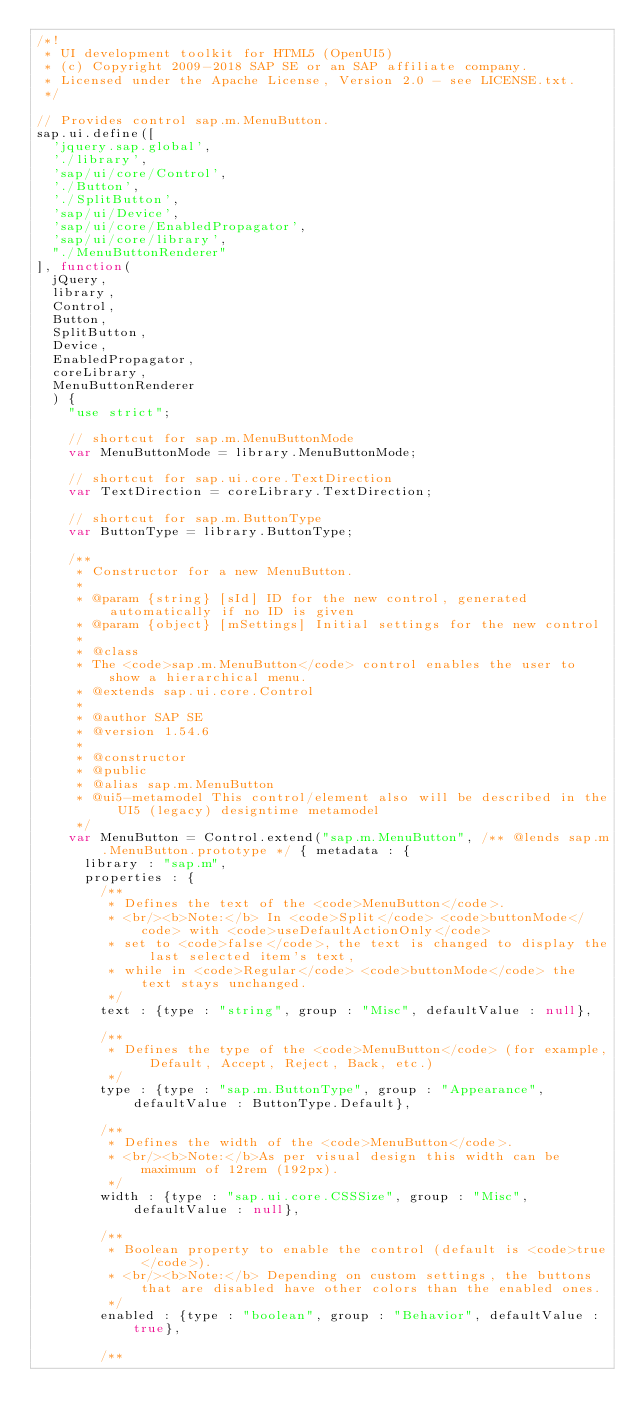<code> <loc_0><loc_0><loc_500><loc_500><_JavaScript_>/*!
 * UI development toolkit for HTML5 (OpenUI5)
 * (c) Copyright 2009-2018 SAP SE or an SAP affiliate company.
 * Licensed under the Apache License, Version 2.0 - see LICENSE.txt.
 */

// Provides control sap.m.MenuButton.
sap.ui.define([
	'jquery.sap.global',
	'./library',
	'sap/ui/core/Control',
	'./Button',
	'./SplitButton',
	'sap/ui/Device',
	'sap/ui/core/EnabledPropagator',
	'sap/ui/core/library',
	"./MenuButtonRenderer"
], function(
	jQuery,
	library,
	Control,
	Button,
	SplitButton,
	Device,
	EnabledPropagator,
	coreLibrary,
	MenuButtonRenderer
	) {
		"use strict";

		// shortcut for sap.m.MenuButtonMode
		var MenuButtonMode = library.MenuButtonMode;

		// shortcut for sap.ui.core.TextDirection
		var TextDirection = coreLibrary.TextDirection;

		// shortcut for sap.m.ButtonType
		var ButtonType = library.ButtonType;

		/**
		 * Constructor for a new MenuButton.
		 *
		 * @param {string} [sId] ID for the new control, generated automatically if no ID is given
		 * @param {object} [mSettings] Initial settings for the new control
		 *
		 * @class
		 * The <code>sap.m.MenuButton</code> control enables the user to show a hierarchical menu.
		 * @extends sap.ui.core.Control
		 *
		 * @author SAP SE
		 * @version 1.54.6
		 *
		 * @constructor
		 * @public
		 * @alias sap.m.MenuButton
		 * @ui5-metamodel This control/element also will be described in the UI5 (legacy) designtime metamodel
		 */
		var MenuButton = Control.extend("sap.m.MenuButton", /** @lends sap.m.MenuButton.prototype */ { metadata : {
			library : "sap.m",
			properties : {
				/**
				 * Defines the text of the <code>MenuButton</code>.
				 * <br/><b>Note:</b> In <code>Split</code> <code>buttonMode</code> with <code>useDefaultActionOnly</code>
				 * set to <code>false</code>, the text is changed to display the last selected item's text,
				 * while in <code>Regular</code> <code>buttonMode</code> the text stays unchanged.
				 */
				text : {type : "string", group : "Misc", defaultValue : null},

				/**
				 * Defines the type of the <code>MenuButton</code> (for example, Default, Accept, Reject, Back, etc.)
				 */
				type : {type : "sap.m.ButtonType", group : "Appearance", defaultValue : ButtonType.Default},

				/**
				 * Defines the width of the <code>MenuButton</code>.
				 * <br/><b>Note:</b>As per visual design this width can be maximum of 12rem (192px).
				 */
				width : {type : "sap.ui.core.CSSSize", group : "Misc", defaultValue : null},

				/**
				 * Boolean property to enable the control (default is <code>true</code>).
				 * <br/><b>Note:</b> Depending on custom settings, the buttons that are disabled have other colors than the enabled ones.
				 */
				enabled : {type : "boolean", group : "Behavior", defaultValue : true},

				/**</code> 